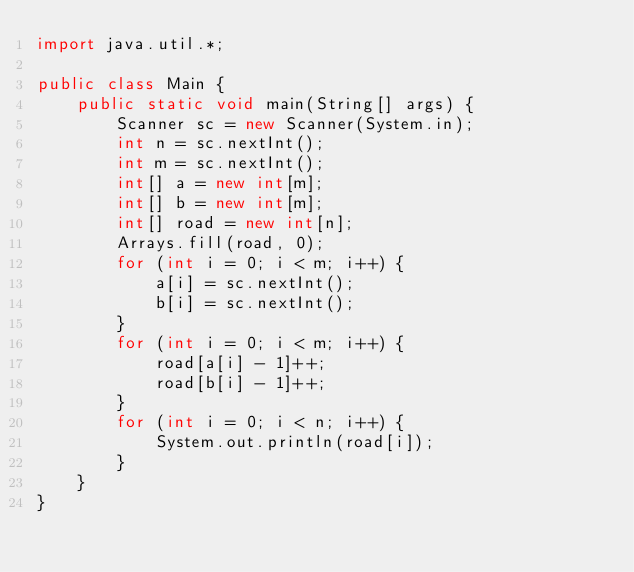<code> <loc_0><loc_0><loc_500><loc_500><_Java_>import java.util.*;

public class Main {
    public static void main(String[] args) {
        Scanner sc = new Scanner(System.in);
        int n = sc.nextInt();
        int m = sc.nextInt();
        int[] a = new int[m];
        int[] b = new int[m];
        int[] road = new int[n];
        Arrays.fill(road, 0);
        for (int i = 0; i < m; i++) {
            a[i] = sc.nextInt();
            b[i] = sc.nextInt();
        }
        for (int i = 0; i < m; i++) {
            road[a[i] - 1]++;
            road[b[i] - 1]++;
        }
        for (int i = 0; i < n; i++) {
            System.out.println(road[i]);
        }
    }
}
</code> 